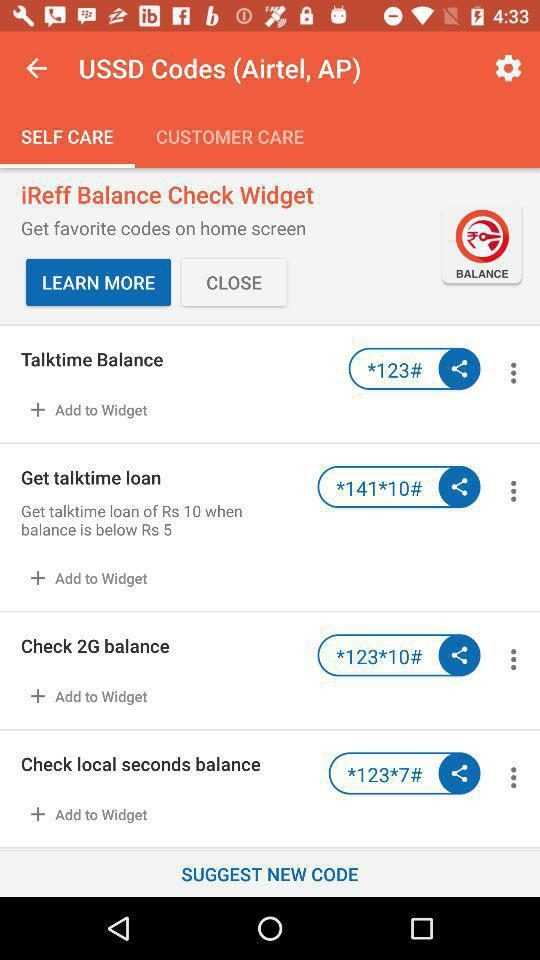How many codes are there for adding to the widget?
Answer the question using a single word or phrase. 4 